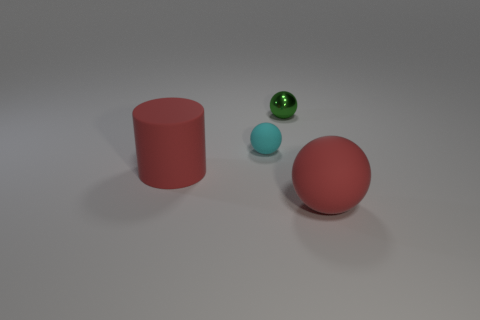What can you infer about the lighting and shadows in the scene? The scene is illuminated by a diffused light source, as indicated by the soft-edged shadows cast by the objects. The shadows extend mainly towards the lower right of the image, suggesting the light is coming from the upper left side. The lack of harsh shadows or bright highlights implies an evenly dispersed light, possibly emanating from an area light source or through thoughtful ambient lighting. 